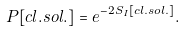Convert formula to latex. <formula><loc_0><loc_0><loc_500><loc_500>P [ c l . s o l . ] = e ^ { - 2 S _ { I } [ c l . s o l . ] } .</formula> 